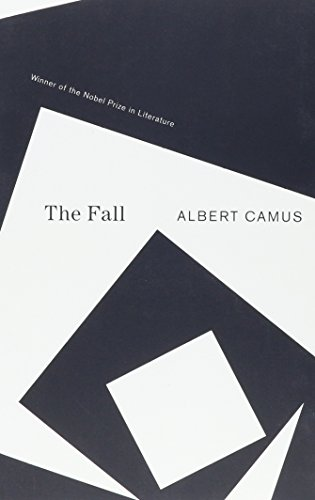What is the title of this book? 'The Fall' is the title of the book, which is a profound literary piece that explores themes of existentialism and human freedom. 